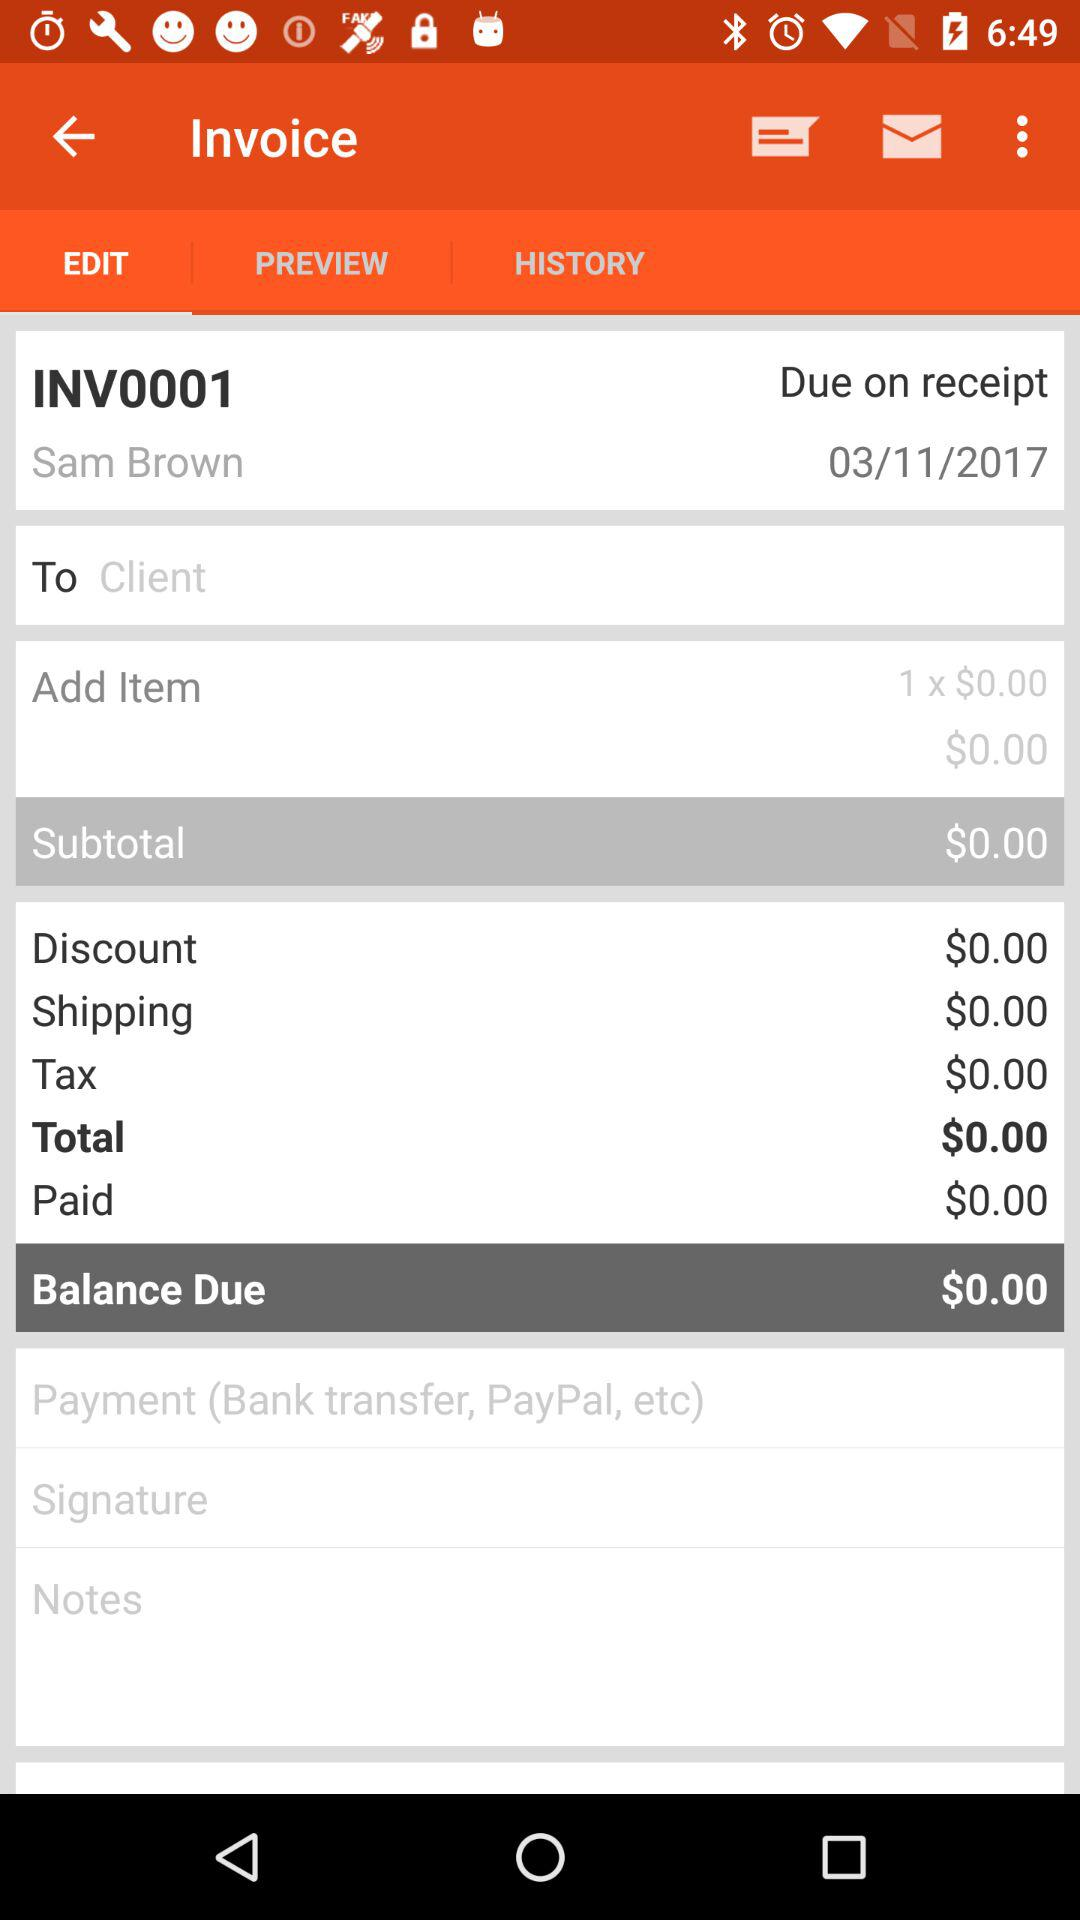How much is the discount? The discount is $0.00. 